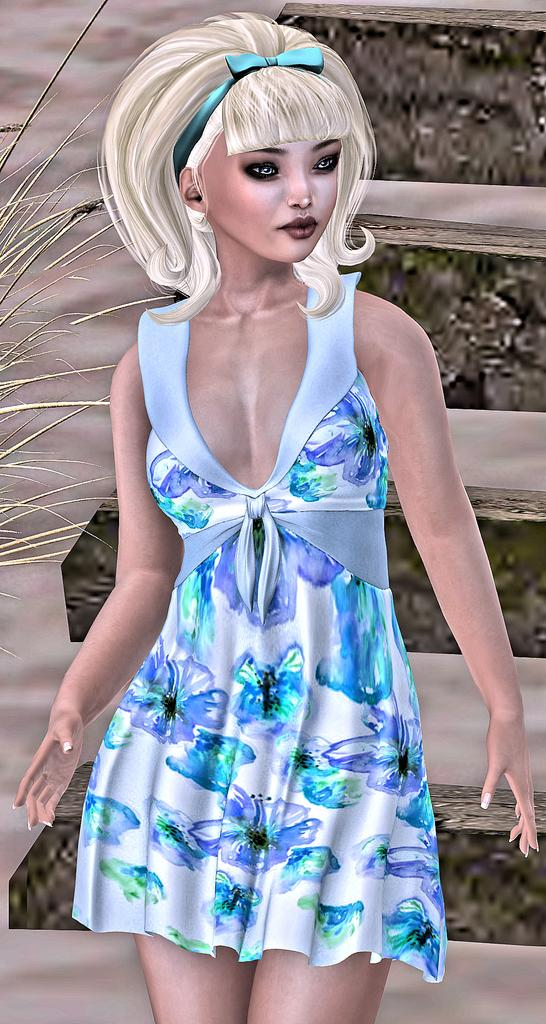What is the main subject of the poster in the image? The poster features a cartoon-style depiction of a girl. What is the girl wearing in the poster? The girl is wearing a white and blue color top. What advice does the girl's grandmother give her in the image? There is no grandmother present in the image, nor is there any dialogue or advice being given. 